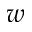Convert formula to latex. <formula><loc_0><loc_0><loc_500><loc_500>w</formula> 